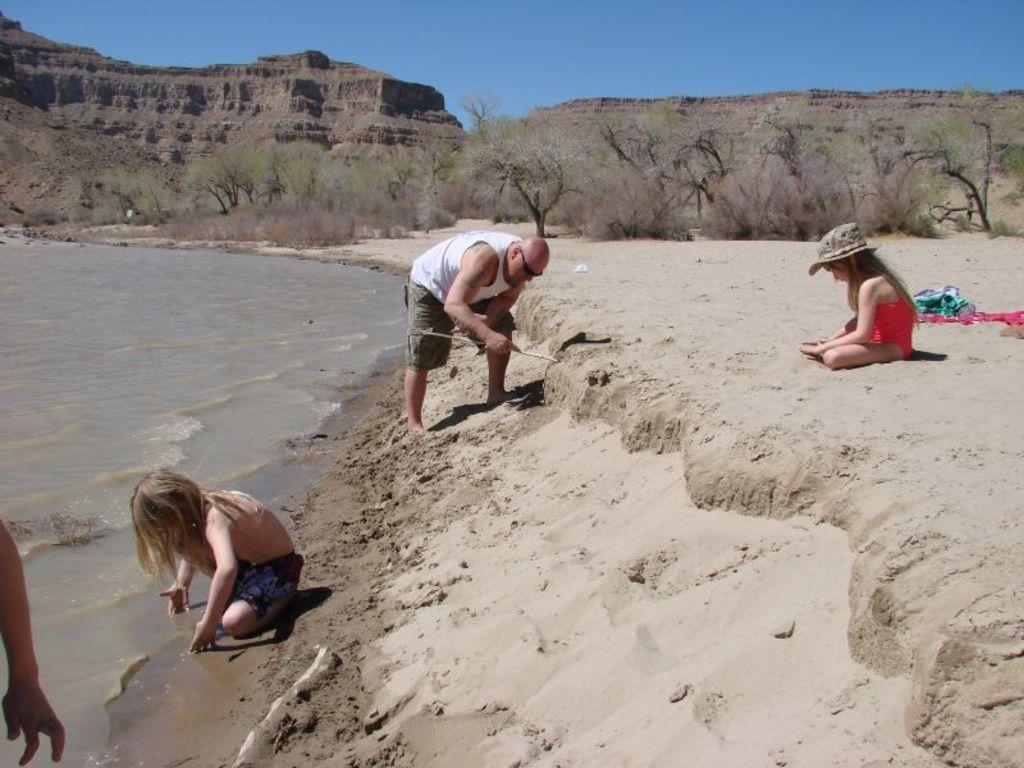In one or two sentences, can you explain what this image depicts? At the top of the image we can see sky, hills and trees. At the bottom of the image we can see lake and persons on the bed of the lake. 